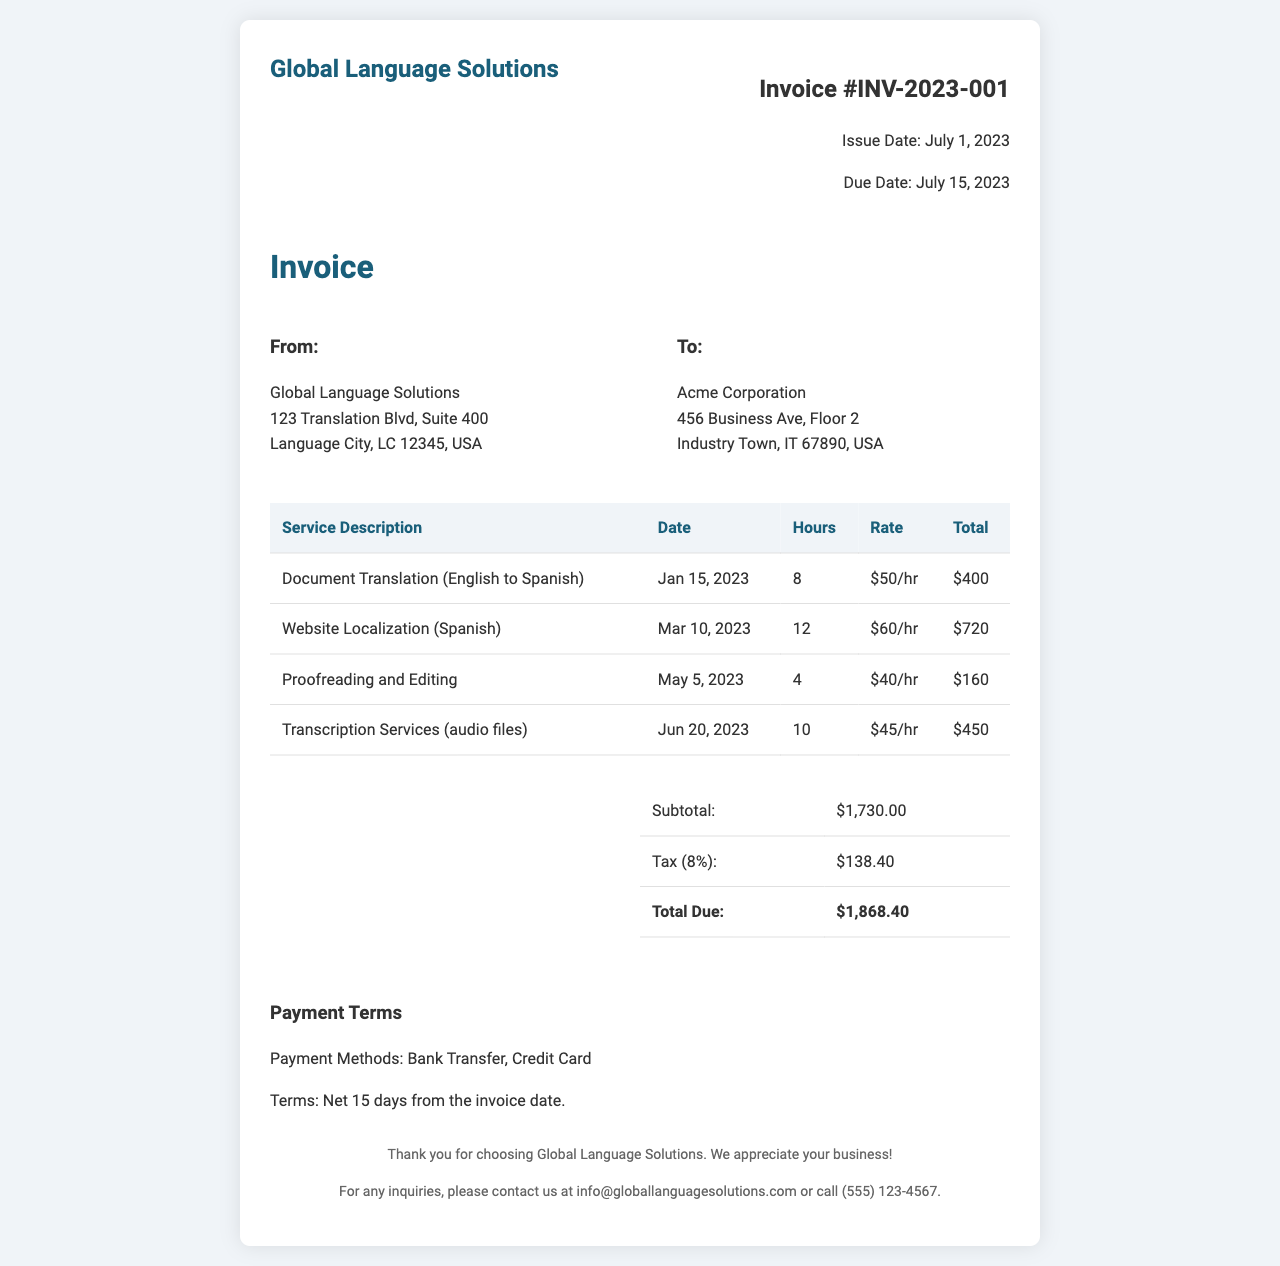what is the invoice number? The invoice number is stated clearly at the top of the invoice under "Invoice #".
Answer: INV-2023-001 what is the issue date of the invoice? The issue date is listed beneath the invoice number.
Answer: July 1, 2023 how many hours were billed for website localization? This information can be found in the services section of the invoice under website localization.
Answer: 12 what is the total due amount? The total due is highlighted in the summary section of the invoice.
Answer: $1,868.40 what service was provided on May 5, 2023? This can be found in the services table, which details the service along with the corresponding date.
Answer: Proofreading and Editing what is the tax percentage applied to the invoice? The invoice includes the tax amount and the percentage used to calculate it.
Answer: 8% what is the payment term for this invoice? The payment terms are clearly stated in the payment terms section of the invoice.
Answer: Net 15 days from the invoice date what was the hourly rate for transcription services? The hourly rate is specified in the service description table under transcription services.
Answer: $45/hr who is the recipient of this invoice? The recipient's name is shown in the "To:" section of the addresses.
Answer: Acme Corporation 